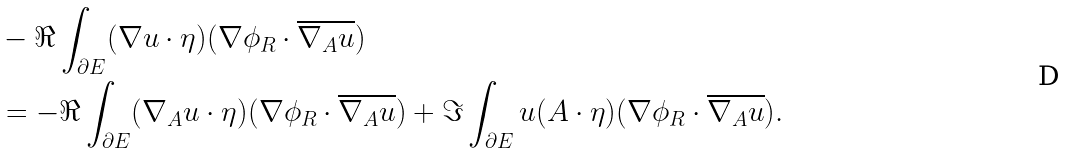Convert formula to latex. <formula><loc_0><loc_0><loc_500><loc_500>& - \Re \int _ { \partial E } ( \nabla u \cdot \eta ) ( \nabla \phi _ { R } \cdot \overline { \nabla _ { A } u } ) \\ & = - \Re \int _ { \partial E } ( \nabla _ { A } u \cdot \eta ) ( \nabla \phi _ { R } \cdot \overline { \nabla _ { A } u } ) + \Im \int _ { \partial E } u ( A \cdot \eta ) ( \nabla \phi _ { R } \cdot \overline { \nabla _ { A } u } ) .</formula> 